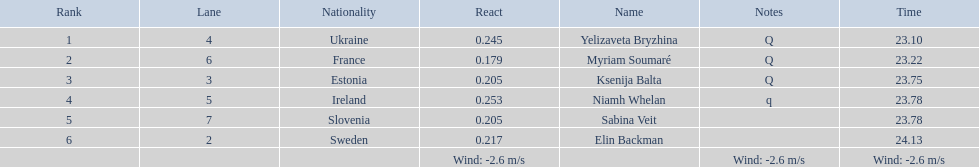What place did elin backman finish the race in? 6. How long did it take him to finish? 24.13. 